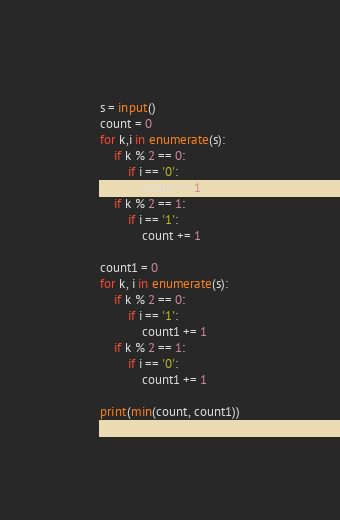Convert code to text. <code><loc_0><loc_0><loc_500><loc_500><_Python_>s = input()
count = 0
for k,i in enumerate(s):
    if k % 2 == 0:
        if i == '0':
            count += 1
    if k % 2 == 1:
        if i == '1':
            count += 1

count1 = 0
for k, i in enumerate(s):
    if k % 2 == 0:
        if i == '1':
            count1 += 1
    if k % 2 == 1:
        if i == '0':
            count1 += 1

print(min(count, count1))</code> 